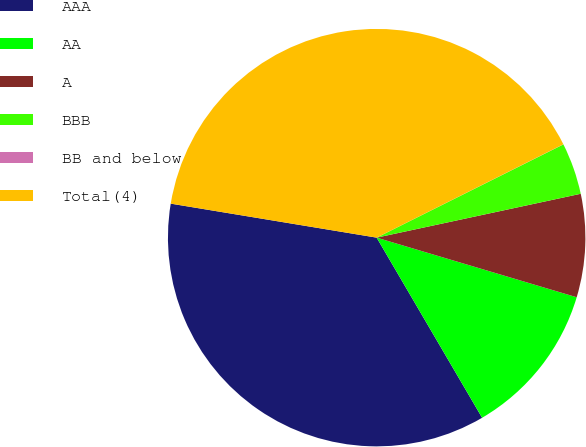<chart> <loc_0><loc_0><loc_500><loc_500><pie_chart><fcel>AAA<fcel>AA<fcel>A<fcel>BBB<fcel>BB and below<fcel>Total(4)<nl><fcel>36.03%<fcel>11.96%<fcel>7.98%<fcel>4.0%<fcel>0.01%<fcel>40.01%<nl></chart> 